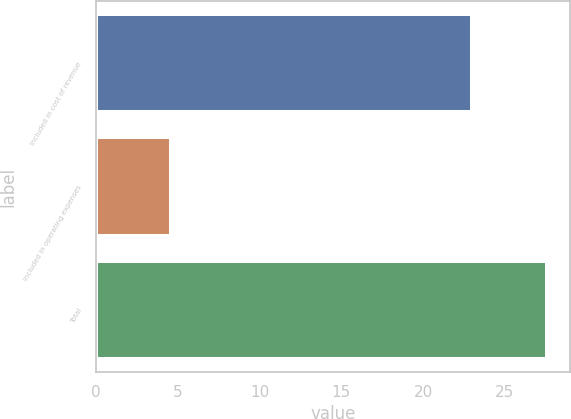Convert chart. <chart><loc_0><loc_0><loc_500><loc_500><bar_chart><fcel>Included in cost of revenue<fcel>Included in operating expenses<fcel>Total<nl><fcel>23<fcel>4.6<fcel>27.6<nl></chart> 